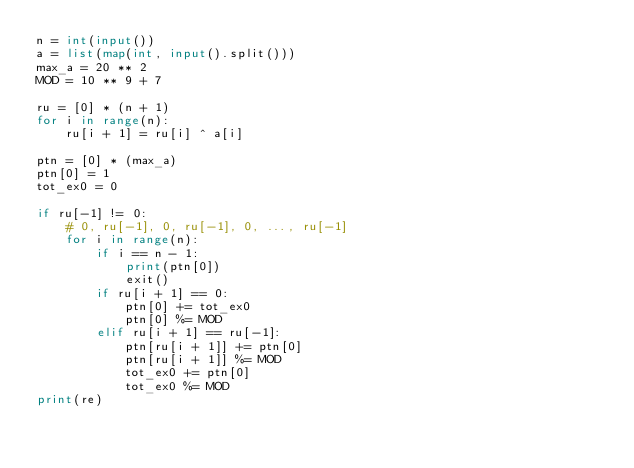<code> <loc_0><loc_0><loc_500><loc_500><_Python_>n = int(input())
a = list(map(int, input().split()))
max_a = 20 ** 2
MOD = 10 ** 9 + 7

ru = [0] * (n + 1)
for i in range(n):
    ru[i + 1] = ru[i] ^ a[i]

ptn = [0] * (max_a)
ptn[0] = 1
tot_ex0 = 0

if ru[-1] != 0:
    # 0, ru[-1], 0, ru[-1], 0, ..., ru[-1]
    for i in range(n):
        if i == n - 1:
            print(ptn[0])
            exit()
        if ru[i + 1] == 0:
            ptn[0] += tot_ex0
            ptn[0] %= MOD
        elif ru[i + 1] == ru[-1]:
            ptn[ru[i + 1]] += ptn[0]
            ptn[ru[i + 1]] %= MOD
            tot_ex0 += ptn[0]
            tot_ex0 %= MOD
print(re)</code> 